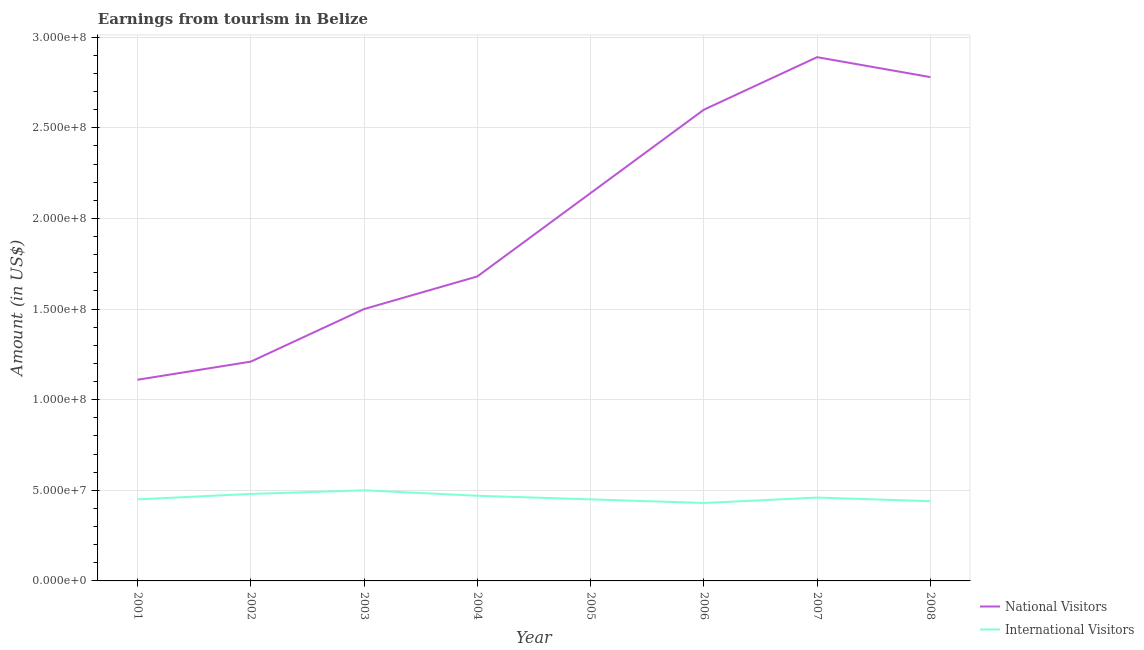What is the amount earned from international visitors in 2008?
Offer a terse response. 4.40e+07. Across all years, what is the maximum amount earned from international visitors?
Provide a short and direct response. 5.00e+07. Across all years, what is the minimum amount earned from national visitors?
Offer a very short reply. 1.11e+08. In which year was the amount earned from international visitors minimum?
Make the answer very short. 2006. What is the total amount earned from national visitors in the graph?
Provide a succinct answer. 1.59e+09. What is the difference between the amount earned from national visitors in 2005 and that in 2006?
Give a very brief answer. -4.60e+07. What is the difference between the amount earned from national visitors in 2005 and the amount earned from international visitors in 2001?
Provide a succinct answer. 1.69e+08. What is the average amount earned from national visitors per year?
Give a very brief answer. 1.99e+08. In the year 2006, what is the difference between the amount earned from national visitors and amount earned from international visitors?
Provide a short and direct response. 2.17e+08. In how many years, is the amount earned from international visitors greater than 250000000 US$?
Your answer should be compact. 0. What is the ratio of the amount earned from international visitors in 2007 to that in 2008?
Your answer should be compact. 1.05. Is the amount earned from international visitors in 2007 less than that in 2008?
Ensure brevity in your answer.  No. What is the difference between the highest and the lowest amount earned from national visitors?
Your answer should be very brief. 1.78e+08. Is the sum of the amount earned from national visitors in 2003 and 2006 greater than the maximum amount earned from international visitors across all years?
Your response must be concise. Yes. Does the amount earned from international visitors monotonically increase over the years?
Your response must be concise. No. Is the amount earned from national visitors strictly less than the amount earned from international visitors over the years?
Offer a terse response. No. What is the difference between two consecutive major ticks on the Y-axis?
Offer a very short reply. 5.00e+07. Are the values on the major ticks of Y-axis written in scientific E-notation?
Your answer should be compact. Yes. Does the graph contain any zero values?
Your answer should be very brief. No. Does the graph contain grids?
Your answer should be very brief. Yes. Where does the legend appear in the graph?
Offer a terse response. Bottom right. What is the title of the graph?
Provide a short and direct response. Earnings from tourism in Belize. Does "Revenue" appear as one of the legend labels in the graph?
Keep it short and to the point. No. What is the label or title of the X-axis?
Offer a very short reply. Year. What is the label or title of the Y-axis?
Offer a terse response. Amount (in US$). What is the Amount (in US$) in National Visitors in 2001?
Offer a very short reply. 1.11e+08. What is the Amount (in US$) of International Visitors in 2001?
Your answer should be compact. 4.50e+07. What is the Amount (in US$) in National Visitors in 2002?
Make the answer very short. 1.21e+08. What is the Amount (in US$) in International Visitors in 2002?
Offer a terse response. 4.80e+07. What is the Amount (in US$) in National Visitors in 2003?
Your response must be concise. 1.50e+08. What is the Amount (in US$) in International Visitors in 2003?
Your answer should be compact. 5.00e+07. What is the Amount (in US$) in National Visitors in 2004?
Give a very brief answer. 1.68e+08. What is the Amount (in US$) of International Visitors in 2004?
Provide a short and direct response. 4.70e+07. What is the Amount (in US$) in National Visitors in 2005?
Give a very brief answer. 2.14e+08. What is the Amount (in US$) of International Visitors in 2005?
Offer a very short reply. 4.50e+07. What is the Amount (in US$) of National Visitors in 2006?
Give a very brief answer. 2.60e+08. What is the Amount (in US$) of International Visitors in 2006?
Your answer should be very brief. 4.30e+07. What is the Amount (in US$) of National Visitors in 2007?
Your answer should be very brief. 2.89e+08. What is the Amount (in US$) of International Visitors in 2007?
Your response must be concise. 4.60e+07. What is the Amount (in US$) of National Visitors in 2008?
Provide a succinct answer. 2.78e+08. What is the Amount (in US$) of International Visitors in 2008?
Make the answer very short. 4.40e+07. Across all years, what is the maximum Amount (in US$) in National Visitors?
Provide a short and direct response. 2.89e+08. Across all years, what is the maximum Amount (in US$) of International Visitors?
Give a very brief answer. 5.00e+07. Across all years, what is the minimum Amount (in US$) in National Visitors?
Ensure brevity in your answer.  1.11e+08. Across all years, what is the minimum Amount (in US$) of International Visitors?
Ensure brevity in your answer.  4.30e+07. What is the total Amount (in US$) in National Visitors in the graph?
Provide a short and direct response. 1.59e+09. What is the total Amount (in US$) in International Visitors in the graph?
Your response must be concise. 3.68e+08. What is the difference between the Amount (in US$) in National Visitors in 2001 and that in 2002?
Your response must be concise. -1.00e+07. What is the difference between the Amount (in US$) of International Visitors in 2001 and that in 2002?
Make the answer very short. -3.00e+06. What is the difference between the Amount (in US$) in National Visitors in 2001 and that in 2003?
Ensure brevity in your answer.  -3.90e+07. What is the difference between the Amount (in US$) of International Visitors in 2001 and that in 2003?
Keep it short and to the point. -5.00e+06. What is the difference between the Amount (in US$) in National Visitors in 2001 and that in 2004?
Your answer should be compact. -5.70e+07. What is the difference between the Amount (in US$) in National Visitors in 2001 and that in 2005?
Ensure brevity in your answer.  -1.03e+08. What is the difference between the Amount (in US$) in International Visitors in 2001 and that in 2005?
Make the answer very short. 0. What is the difference between the Amount (in US$) of National Visitors in 2001 and that in 2006?
Offer a very short reply. -1.49e+08. What is the difference between the Amount (in US$) in International Visitors in 2001 and that in 2006?
Offer a very short reply. 2.00e+06. What is the difference between the Amount (in US$) of National Visitors in 2001 and that in 2007?
Give a very brief answer. -1.78e+08. What is the difference between the Amount (in US$) in International Visitors in 2001 and that in 2007?
Your answer should be compact. -1.00e+06. What is the difference between the Amount (in US$) in National Visitors in 2001 and that in 2008?
Provide a short and direct response. -1.67e+08. What is the difference between the Amount (in US$) in National Visitors in 2002 and that in 2003?
Ensure brevity in your answer.  -2.90e+07. What is the difference between the Amount (in US$) of International Visitors in 2002 and that in 2003?
Your answer should be compact. -2.00e+06. What is the difference between the Amount (in US$) in National Visitors in 2002 and that in 2004?
Provide a succinct answer. -4.70e+07. What is the difference between the Amount (in US$) of International Visitors in 2002 and that in 2004?
Offer a very short reply. 1.00e+06. What is the difference between the Amount (in US$) of National Visitors in 2002 and that in 2005?
Your response must be concise. -9.30e+07. What is the difference between the Amount (in US$) of National Visitors in 2002 and that in 2006?
Provide a succinct answer. -1.39e+08. What is the difference between the Amount (in US$) of National Visitors in 2002 and that in 2007?
Ensure brevity in your answer.  -1.68e+08. What is the difference between the Amount (in US$) in National Visitors in 2002 and that in 2008?
Offer a very short reply. -1.57e+08. What is the difference between the Amount (in US$) of International Visitors in 2002 and that in 2008?
Ensure brevity in your answer.  4.00e+06. What is the difference between the Amount (in US$) of National Visitors in 2003 and that in 2004?
Provide a short and direct response. -1.80e+07. What is the difference between the Amount (in US$) of National Visitors in 2003 and that in 2005?
Offer a terse response. -6.40e+07. What is the difference between the Amount (in US$) in National Visitors in 2003 and that in 2006?
Make the answer very short. -1.10e+08. What is the difference between the Amount (in US$) in National Visitors in 2003 and that in 2007?
Your answer should be very brief. -1.39e+08. What is the difference between the Amount (in US$) in National Visitors in 2003 and that in 2008?
Give a very brief answer. -1.28e+08. What is the difference between the Amount (in US$) of International Visitors in 2003 and that in 2008?
Provide a succinct answer. 6.00e+06. What is the difference between the Amount (in US$) in National Visitors in 2004 and that in 2005?
Offer a terse response. -4.60e+07. What is the difference between the Amount (in US$) in International Visitors in 2004 and that in 2005?
Offer a very short reply. 2.00e+06. What is the difference between the Amount (in US$) of National Visitors in 2004 and that in 2006?
Offer a very short reply. -9.20e+07. What is the difference between the Amount (in US$) in National Visitors in 2004 and that in 2007?
Make the answer very short. -1.21e+08. What is the difference between the Amount (in US$) of International Visitors in 2004 and that in 2007?
Provide a succinct answer. 1.00e+06. What is the difference between the Amount (in US$) in National Visitors in 2004 and that in 2008?
Provide a short and direct response. -1.10e+08. What is the difference between the Amount (in US$) in International Visitors in 2004 and that in 2008?
Offer a very short reply. 3.00e+06. What is the difference between the Amount (in US$) in National Visitors in 2005 and that in 2006?
Ensure brevity in your answer.  -4.60e+07. What is the difference between the Amount (in US$) in International Visitors in 2005 and that in 2006?
Ensure brevity in your answer.  2.00e+06. What is the difference between the Amount (in US$) of National Visitors in 2005 and that in 2007?
Provide a short and direct response. -7.50e+07. What is the difference between the Amount (in US$) in International Visitors in 2005 and that in 2007?
Give a very brief answer. -1.00e+06. What is the difference between the Amount (in US$) of National Visitors in 2005 and that in 2008?
Provide a short and direct response. -6.40e+07. What is the difference between the Amount (in US$) in International Visitors in 2005 and that in 2008?
Ensure brevity in your answer.  1.00e+06. What is the difference between the Amount (in US$) in National Visitors in 2006 and that in 2007?
Offer a very short reply. -2.90e+07. What is the difference between the Amount (in US$) of International Visitors in 2006 and that in 2007?
Your answer should be compact. -3.00e+06. What is the difference between the Amount (in US$) in National Visitors in 2006 and that in 2008?
Provide a succinct answer. -1.80e+07. What is the difference between the Amount (in US$) of National Visitors in 2007 and that in 2008?
Give a very brief answer. 1.10e+07. What is the difference between the Amount (in US$) of National Visitors in 2001 and the Amount (in US$) of International Visitors in 2002?
Offer a very short reply. 6.30e+07. What is the difference between the Amount (in US$) in National Visitors in 2001 and the Amount (in US$) in International Visitors in 2003?
Offer a terse response. 6.10e+07. What is the difference between the Amount (in US$) in National Visitors in 2001 and the Amount (in US$) in International Visitors in 2004?
Offer a very short reply. 6.40e+07. What is the difference between the Amount (in US$) of National Visitors in 2001 and the Amount (in US$) of International Visitors in 2005?
Keep it short and to the point. 6.60e+07. What is the difference between the Amount (in US$) in National Visitors in 2001 and the Amount (in US$) in International Visitors in 2006?
Keep it short and to the point. 6.80e+07. What is the difference between the Amount (in US$) in National Visitors in 2001 and the Amount (in US$) in International Visitors in 2007?
Offer a very short reply. 6.50e+07. What is the difference between the Amount (in US$) of National Visitors in 2001 and the Amount (in US$) of International Visitors in 2008?
Offer a very short reply. 6.70e+07. What is the difference between the Amount (in US$) of National Visitors in 2002 and the Amount (in US$) of International Visitors in 2003?
Provide a short and direct response. 7.10e+07. What is the difference between the Amount (in US$) in National Visitors in 2002 and the Amount (in US$) in International Visitors in 2004?
Your answer should be compact. 7.40e+07. What is the difference between the Amount (in US$) of National Visitors in 2002 and the Amount (in US$) of International Visitors in 2005?
Provide a short and direct response. 7.60e+07. What is the difference between the Amount (in US$) of National Visitors in 2002 and the Amount (in US$) of International Visitors in 2006?
Your answer should be very brief. 7.80e+07. What is the difference between the Amount (in US$) in National Visitors in 2002 and the Amount (in US$) in International Visitors in 2007?
Give a very brief answer. 7.50e+07. What is the difference between the Amount (in US$) in National Visitors in 2002 and the Amount (in US$) in International Visitors in 2008?
Make the answer very short. 7.70e+07. What is the difference between the Amount (in US$) of National Visitors in 2003 and the Amount (in US$) of International Visitors in 2004?
Keep it short and to the point. 1.03e+08. What is the difference between the Amount (in US$) in National Visitors in 2003 and the Amount (in US$) in International Visitors in 2005?
Offer a terse response. 1.05e+08. What is the difference between the Amount (in US$) in National Visitors in 2003 and the Amount (in US$) in International Visitors in 2006?
Offer a very short reply. 1.07e+08. What is the difference between the Amount (in US$) in National Visitors in 2003 and the Amount (in US$) in International Visitors in 2007?
Make the answer very short. 1.04e+08. What is the difference between the Amount (in US$) in National Visitors in 2003 and the Amount (in US$) in International Visitors in 2008?
Provide a short and direct response. 1.06e+08. What is the difference between the Amount (in US$) of National Visitors in 2004 and the Amount (in US$) of International Visitors in 2005?
Give a very brief answer. 1.23e+08. What is the difference between the Amount (in US$) of National Visitors in 2004 and the Amount (in US$) of International Visitors in 2006?
Give a very brief answer. 1.25e+08. What is the difference between the Amount (in US$) in National Visitors in 2004 and the Amount (in US$) in International Visitors in 2007?
Give a very brief answer. 1.22e+08. What is the difference between the Amount (in US$) in National Visitors in 2004 and the Amount (in US$) in International Visitors in 2008?
Provide a short and direct response. 1.24e+08. What is the difference between the Amount (in US$) of National Visitors in 2005 and the Amount (in US$) of International Visitors in 2006?
Provide a succinct answer. 1.71e+08. What is the difference between the Amount (in US$) of National Visitors in 2005 and the Amount (in US$) of International Visitors in 2007?
Ensure brevity in your answer.  1.68e+08. What is the difference between the Amount (in US$) of National Visitors in 2005 and the Amount (in US$) of International Visitors in 2008?
Your answer should be compact. 1.70e+08. What is the difference between the Amount (in US$) of National Visitors in 2006 and the Amount (in US$) of International Visitors in 2007?
Your answer should be compact. 2.14e+08. What is the difference between the Amount (in US$) in National Visitors in 2006 and the Amount (in US$) in International Visitors in 2008?
Offer a terse response. 2.16e+08. What is the difference between the Amount (in US$) of National Visitors in 2007 and the Amount (in US$) of International Visitors in 2008?
Your answer should be very brief. 2.45e+08. What is the average Amount (in US$) in National Visitors per year?
Offer a terse response. 1.99e+08. What is the average Amount (in US$) in International Visitors per year?
Your response must be concise. 4.60e+07. In the year 2001, what is the difference between the Amount (in US$) of National Visitors and Amount (in US$) of International Visitors?
Your answer should be very brief. 6.60e+07. In the year 2002, what is the difference between the Amount (in US$) in National Visitors and Amount (in US$) in International Visitors?
Your answer should be compact. 7.30e+07. In the year 2004, what is the difference between the Amount (in US$) in National Visitors and Amount (in US$) in International Visitors?
Your answer should be compact. 1.21e+08. In the year 2005, what is the difference between the Amount (in US$) in National Visitors and Amount (in US$) in International Visitors?
Your response must be concise. 1.69e+08. In the year 2006, what is the difference between the Amount (in US$) in National Visitors and Amount (in US$) in International Visitors?
Your answer should be compact. 2.17e+08. In the year 2007, what is the difference between the Amount (in US$) in National Visitors and Amount (in US$) in International Visitors?
Make the answer very short. 2.43e+08. In the year 2008, what is the difference between the Amount (in US$) of National Visitors and Amount (in US$) of International Visitors?
Offer a very short reply. 2.34e+08. What is the ratio of the Amount (in US$) of National Visitors in 2001 to that in 2002?
Keep it short and to the point. 0.92. What is the ratio of the Amount (in US$) of International Visitors in 2001 to that in 2002?
Provide a short and direct response. 0.94. What is the ratio of the Amount (in US$) in National Visitors in 2001 to that in 2003?
Provide a short and direct response. 0.74. What is the ratio of the Amount (in US$) in National Visitors in 2001 to that in 2004?
Provide a short and direct response. 0.66. What is the ratio of the Amount (in US$) in International Visitors in 2001 to that in 2004?
Make the answer very short. 0.96. What is the ratio of the Amount (in US$) of National Visitors in 2001 to that in 2005?
Give a very brief answer. 0.52. What is the ratio of the Amount (in US$) of National Visitors in 2001 to that in 2006?
Give a very brief answer. 0.43. What is the ratio of the Amount (in US$) in International Visitors in 2001 to that in 2006?
Provide a short and direct response. 1.05. What is the ratio of the Amount (in US$) in National Visitors in 2001 to that in 2007?
Make the answer very short. 0.38. What is the ratio of the Amount (in US$) in International Visitors in 2001 to that in 2007?
Keep it short and to the point. 0.98. What is the ratio of the Amount (in US$) in National Visitors in 2001 to that in 2008?
Make the answer very short. 0.4. What is the ratio of the Amount (in US$) of International Visitors in 2001 to that in 2008?
Provide a succinct answer. 1.02. What is the ratio of the Amount (in US$) of National Visitors in 2002 to that in 2003?
Make the answer very short. 0.81. What is the ratio of the Amount (in US$) of International Visitors in 2002 to that in 2003?
Ensure brevity in your answer.  0.96. What is the ratio of the Amount (in US$) in National Visitors in 2002 to that in 2004?
Provide a short and direct response. 0.72. What is the ratio of the Amount (in US$) in International Visitors in 2002 to that in 2004?
Give a very brief answer. 1.02. What is the ratio of the Amount (in US$) in National Visitors in 2002 to that in 2005?
Make the answer very short. 0.57. What is the ratio of the Amount (in US$) in International Visitors in 2002 to that in 2005?
Your answer should be very brief. 1.07. What is the ratio of the Amount (in US$) in National Visitors in 2002 to that in 2006?
Offer a very short reply. 0.47. What is the ratio of the Amount (in US$) in International Visitors in 2002 to that in 2006?
Your response must be concise. 1.12. What is the ratio of the Amount (in US$) of National Visitors in 2002 to that in 2007?
Provide a succinct answer. 0.42. What is the ratio of the Amount (in US$) of International Visitors in 2002 to that in 2007?
Provide a succinct answer. 1.04. What is the ratio of the Amount (in US$) in National Visitors in 2002 to that in 2008?
Provide a short and direct response. 0.44. What is the ratio of the Amount (in US$) of National Visitors in 2003 to that in 2004?
Your response must be concise. 0.89. What is the ratio of the Amount (in US$) in International Visitors in 2003 to that in 2004?
Your answer should be very brief. 1.06. What is the ratio of the Amount (in US$) in National Visitors in 2003 to that in 2005?
Offer a very short reply. 0.7. What is the ratio of the Amount (in US$) in International Visitors in 2003 to that in 2005?
Make the answer very short. 1.11. What is the ratio of the Amount (in US$) in National Visitors in 2003 to that in 2006?
Provide a short and direct response. 0.58. What is the ratio of the Amount (in US$) in International Visitors in 2003 to that in 2006?
Your response must be concise. 1.16. What is the ratio of the Amount (in US$) in National Visitors in 2003 to that in 2007?
Your answer should be very brief. 0.52. What is the ratio of the Amount (in US$) in International Visitors in 2003 to that in 2007?
Offer a terse response. 1.09. What is the ratio of the Amount (in US$) in National Visitors in 2003 to that in 2008?
Your response must be concise. 0.54. What is the ratio of the Amount (in US$) of International Visitors in 2003 to that in 2008?
Provide a succinct answer. 1.14. What is the ratio of the Amount (in US$) of National Visitors in 2004 to that in 2005?
Your answer should be very brief. 0.79. What is the ratio of the Amount (in US$) of International Visitors in 2004 to that in 2005?
Give a very brief answer. 1.04. What is the ratio of the Amount (in US$) of National Visitors in 2004 to that in 2006?
Make the answer very short. 0.65. What is the ratio of the Amount (in US$) of International Visitors in 2004 to that in 2006?
Provide a succinct answer. 1.09. What is the ratio of the Amount (in US$) of National Visitors in 2004 to that in 2007?
Ensure brevity in your answer.  0.58. What is the ratio of the Amount (in US$) of International Visitors in 2004 to that in 2007?
Offer a very short reply. 1.02. What is the ratio of the Amount (in US$) of National Visitors in 2004 to that in 2008?
Give a very brief answer. 0.6. What is the ratio of the Amount (in US$) of International Visitors in 2004 to that in 2008?
Provide a short and direct response. 1.07. What is the ratio of the Amount (in US$) of National Visitors in 2005 to that in 2006?
Keep it short and to the point. 0.82. What is the ratio of the Amount (in US$) in International Visitors in 2005 to that in 2006?
Make the answer very short. 1.05. What is the ratio of the Amount (in US$) in National Visitors in 2005 to that in 2007?
Ensure brevity in your answer.  0.74. What is the ratio of the Amount (in US$) in International Visitors in 2005 to that in 2007?
Give a very brief answer. 0.98. What is the ratio of the Amount (in US$) of National Visitors in 2005 to that in 2008?
Make the answer very short. 0.77. What is the ratio of the Amount (in US$) of International Visitors in 2005 to that in 2008?
Offer a terse response. 1.02. What is the ratio of the Amount (in US$) in National Visitors in 2006 to that in 2007?
Your response must be concise. 0.9. What is the ratio of the Amount (in US$) of International Visitors in 2006 to that in 2007?
Your response must be concise. 0.93. What is the ratio of the Amount (in US$) in National Visitors in 2006 to that in 2008?
Offer a terse response. 0.94. What is the ratio of the Amount (in US$) in International Visitors in 2006 to that in 2008?
Keep it short and to the point. 0.98. What is the ratio of the Amount (in US$) in National Visitors in 2007 to that in 2008?
Your response must be concise. 1.04. What is the ratio of the Amount (in US$) in International Visitors in 2007 to that in 2008?
Give a very brief answer. 1.05. What is the difference between the highest and the second highest Amount (in US$) of National Visitors?
Make the answer very short. 1.10e+07. What is the difference between the highest and the lowest Amount (in US$) in National Visitors?
Provide a succinct answer. 1.78e+08. 